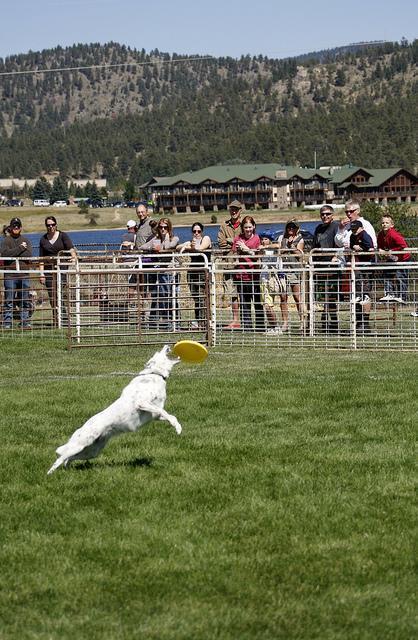How many people are in the picture?
Give a very brief answer. 5. How many elephants are standing?
Give a very brief answer. 0. 